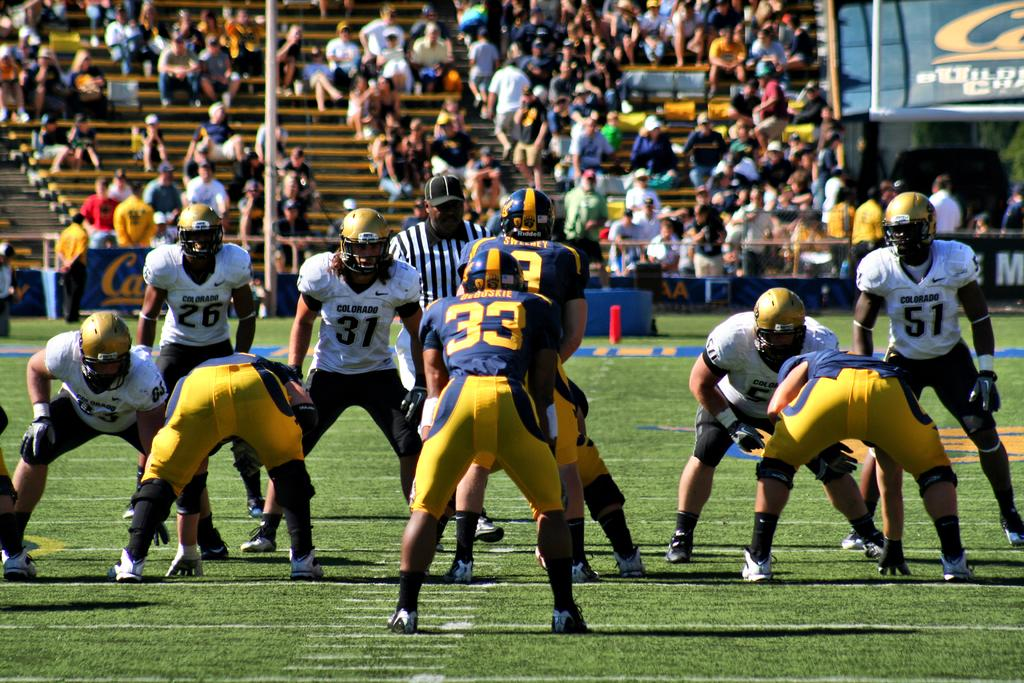Who or what can be seen in the image? There are people in the image. What objects are present in the image that people might sit on? There are benches in the image. What type of advertisement or signage is visible in the image? There are hoardings in the image. What vertical structure can be seen in the image? There is a pole in the image. What are some people doing in the image? Some people are sitting in the image. What protective gear is being worn by some people in the image? Some people are wearing helmets in the image. What is the ground covered with in the image? The land is covered with grass in the image. What type of rice is being cooked in the image? There is no rice present in the image. What thoughts are being expressed by the people in the image? The image does not show or convey any thoughts of the people. 